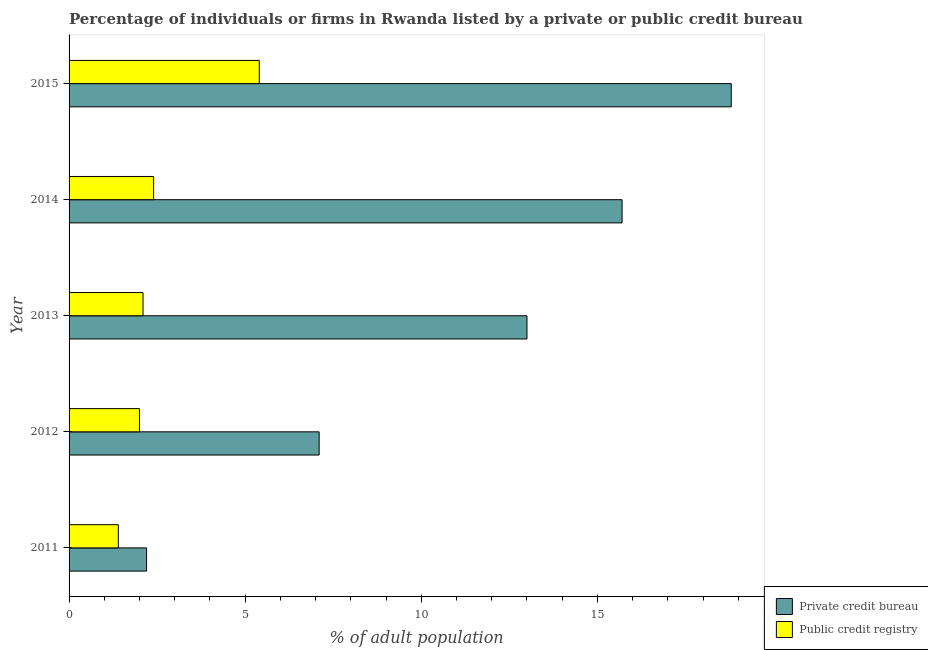How many groups of bars are there?
Provide a short and direct response. 5. Are the number of bars per tick equal to the number of legend labels?
Give a very brief answer. Yes. How many bars are there on the 3rd tick from the top?
Your answer should be compact. 2. How many bars are there on the 3rd tick from the bottom?
Your answer should be compact. 2. What is the label of the 3rd group of bars from the top?
Ensure brevity in your answer.  2013. In how many cases, is the number of bars for a given year not equal to the number of legend labels?
Ensure brevity in your answer.  0. What is the percentage of firms listed by public credit bureau in 2012?
Provide a short and direct response. 2. Across all years, what is the minimum percentage of firms listed by public credit bureau?
Offer a very short reply. 1.4. In which year was the percentage of firms listed by private credit bureau maximum?
Offer a very short reply. 2015. What is the total percentage of firms listed by public credit bureau in the graph?
Your answer should be compact. 13.3. What is the difference between the percentage of firms listed by private credit bureau in 2013 and that in 2015?
Your response must be concise. -5.8. What is the difference between the percentage of firms listed by public credit bureau in 2013 and the percentage of firms listed by private credit bureau in 2015?
Offer a very short reply. -16.7. What is the average percentage of firms listed by private credit bureau per year?
Provide a short and direct response. 11.36. What is the ratio of the percentage of firms listed by private credit bureau in 2014 to that in 2015?
Provide a short and direct response. 0.83. In how many years, is the percentage of firms listed by private credit bureau greater than the average percentage of firms listed by private credit bureau taken over all years?
Make the answer very short. 3. What does the 1st bar from the top in 2015 represents?
Your response must be concise. Public credit registry. What does the 1st bar from the bottom in 2013 represents?
Your answer should be very brief. Private credit bureau. How many bars are there?
Give a very brief answer. 10. Are all the bars in the graph horizontal?
Your response must be concise. Yes. What is the difference between two consecutive major ticks on the X-axis?
Keep it short and to the point. 5. Are the values on the major ticks of X-axis written in scientific E-notation?
Your response must be concise. No. Does the graph contain any zero values?
Ensure brevity in your answer.  No. Does the graph contain grids?
Your answer should be very brief. No. How are the legend labels stacked?
Provide a succinct answer. Vertical. What is the title of the graph?
Your answer should be very brief. Percentage of individuals or firms in Rwanda listed by a private or public credit bureau. Does "Girls" appear as one of the legend labels in the graph?
Ensure brevity in your answer.  No. What is the label or title of the X-axis?
Keep it short and to the point. % of adult population. What is the label or title of the Y-axis?
Offer a terse response. Year. What is the % of adult population in Private credit bureau in 2011?
Provide a succinct answer. 2.2. What is the % of adult population of Public credit registry in 2011?
Your answer should be compact. 1.4. What is the % of adult population in Private credit bureau in 2013?
Your answer should be compact. 13. What is the % of adult population of Public credit registry in 2014?
Make the answer very short. 2.4. What is the % of adult population of Private credit bureau in 2015?
Offer a terse response. 18.8. What is the % of adult population in Public credit registry in 2015?
Keep it short and to the point. 5.4. Across all years, what is the maximum % of adult population of Public credit registry?
Provide a succinct answer. 5.4. Across all years, what is the minimum % of adult population of Public credit registry?
Your answer should be very brief. 1.4. What is the total % of adult population of Private credit bureau in the graph?
Offer a terse response. 56.8. What is the difference between the % of adult population of Private credit bureau in 2011 and that in 2012?
Make the answer very short. -4.9. What is the difference between the % of adult population in Public credit registry in 2011 and that in 2012?
Provide a succinct answer. -0.6. What is the difference between the % of adult population of Public credit registry in 2011 and that in 2013?
Your answer should be compact. -0.7. What is the difference between the % of adult population of Private credit bureau in 2011 and that in 2014?
Keep it short and to the point. -13.5. What is the difference between the % of adult population of Public credit registry in 2011 and that in 2014?
Your answer should be very brief. -1. What is the difference between the % of adult population of Private credit bureau in 2011 and that in 2015?
Make the answer very short. -16.6. What is the difference between the % of adult population of Private credit bureau in 2012 and that in 2013?
Keep it short and to the point. -5.9. What is the difference between the % of adult population in Private credit bureau in 2012 and that in 2014?
Offer a terse response. -8.6. What is the difference between the % of adult population in Public credit registry in 2012 and that in 2014?
Offer a very short reply. -0.4. What is the difference between the % of adult population of Public credit registry in 2012 and that in 2015?
Provide a succinct answer. -3.4. What is the difference between the % of adult population of Public credit registry in 2013 and that in 2014?
Ensure brevity in your answer.  -0.3. What is the difference between the % of adult population of Public credit registry in 2013 and that in 2015?
Ensure brevity in your answer.  -3.3. What is the difference between the % of adult population in Public credit registry in 2014 and that in 2015?
Your answer should be very brief. -3. What is the difference between the % of adult population of Private credit bureau in 2011 and the % of adult population of Public credit registry in 2012?
Your response must be concise. 0.2. What is the difference between the % of adult population in Private credit bureau in 2011 and the % of adult population in Public credit registry in 2013?
Offer a very short reply. 0.1. What is the difference between the % of adult population in Private credit bureau in 2011 and the % of adult population in Public credit registry in 2015?
Keep it short and to the point. -3.2. What is the difference between the % of adult population in Private credit bureau in 2013 and the % of adult population in Public credit registry in 2014?
Offer a terse response. 10.6. What is the difference between the % of adult population in Private credit bureau in 2013 and the % of adult population in Public credit registry in 2015?
Give a very brief answer. 7.6. What is the difference between the % of adult population of Private credit bureau in 2014 and the % of adult population of Public credit registry in 2015?
Give a very brief answer. 10.3. What is the average % of adult population in Private credit bureau per year?
Your answer should be compact. 11.36. What is the average % of adult population in Public credit registry per year?
Make the answer very short. 2.66. In the year 2012, what is the difference between the % of adult population in Private credit bureau and % of adult population in Public credit registry?
Offer a very short reply. 5.1. In the year 2013, what is the difference between the % of adult population in Private credit bureau and % of adult population in Public credit registry?
Make the answer very short. 10.9. In the year 2015, what is the difference between the % of adult population of Private credit bureau and % of adult population of Public credit registry?
Provide a succinct answer. 13.4. What is the ratio of the % of adult population in Private credit bureau in 2011 to that in 2012?
Offer a very short reply. 0.31. What is the ratio of the % of adult population in Public credit registry in 2011 to that in 2012?
Your answer should be very brief. 0.7. What is the ratio of the % of adult population in Private credit bureau in 2011 to that in 2013?
Provide a short and direct response. 0.17. What is the ratio of the % of adult population of Public credit registry in 2011 to that in 2013?
Keep it short and to the point. 0.67. What is the ratio of the % of adult population of Private credit bureau in 2011 to that in 2014?
Provide a succinct answer. 0.14. What is the ratio of the % of adult population of Public credit registry in 2011 to that in 2014?
Provide a short and direct response. 0.58. What is the ratio of the % of adult population of Private credit bureau in 2011 to that in 2015?
Your answer should be compact. 0.12. What is the ratio of the % of adult population in Public credit registry in 2011 to that in 2015?
Provide a short and direct response. 0.26. What is the ratio of the % of adult population of Private credit bureau in 2012 to that in 2013?
Ensure brevity in your answer.  0.55. What is the ratio of the % of adult population of Private credit bureau in 2012 to that in 2014?
Provide a short and direct response. 0.45. What is the ratio of the % of adult population in Private credit bureau in 2012 to that in 2015?
Ensure brevity in your answer.  0.38. What is the ratio of the % of adult population in Public credit registry in 2012 to that in 2015?
Give a very brief answer. 0.37. What is the ratio of the % of adult population in Private credit bureau in 2013 to that in 2014?
Provide a short and direct response. 0.83. What is the ratio of the % of adult population in Public credit registry in 2013 to that in 2014?
Make the answer very short. 0.88. What is the ratio of the % of adult population in Private credit bureau in 2013 to that in 2015?
Give a very brief answer. 0.69. What is the ratio of the % of adult population in Public credit registry in 2013 to that in 2015?
Your response must be concise. 0.39. What is the ratio of the % of adult population in Private credit bureau in 2014 to that in 2015?
Make the answer very short. 0.84. What is the ratio of the % of adult population in Public credit registry in 2014 to that in 2015?
Offer a very short reply. 0.44. What is the difference between the highest and the lowest % of adult population in Private credit bureau?
Make the answer very short. 16.6. What is the difference between the highest and the lowest % of adult population of Public credit registry?
Make the answer very short. 4. 